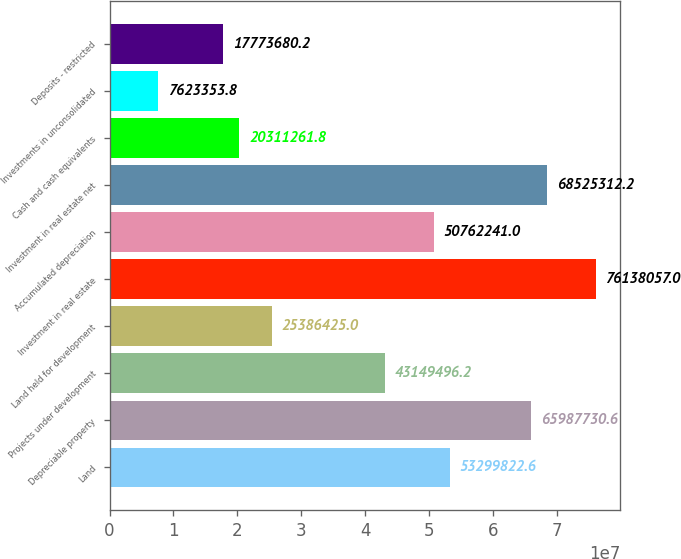Convert chart. <chart><loc_0><loc_0><loc_500><loc_500><bar_chart><fcel>Land<fcel>Depreciable property<fcel>Projects under development<fcel>Land held for development<fcel>Investment in real estate<fcel>Accumulated depreciation<fcel>Investment in real estate net<fcel>Cash and cash equivalents<fcel>Investments in unconsolidated<fcel>Deposits - restricted<nl><fcel>5.32998e+07<fcel>6.59877e+07<fcel>4.31495e+07<fcel>2.53864e+07<fcel>7.61381e+07<fcel>5.07622e+07<fcel>6.85253e+07<fcel>2.03113e+07<fcel>7.62335e+06<fcel>1.77737e+07<nl></chart> 